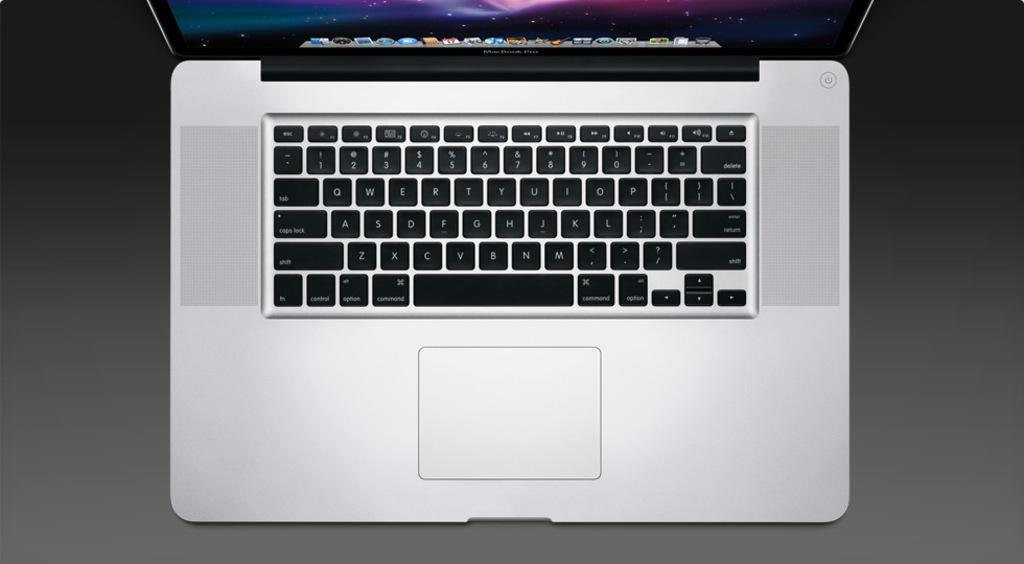Provide a one-sentence caption for the provided image. Looking down on an open Macintosh laptop computer. 